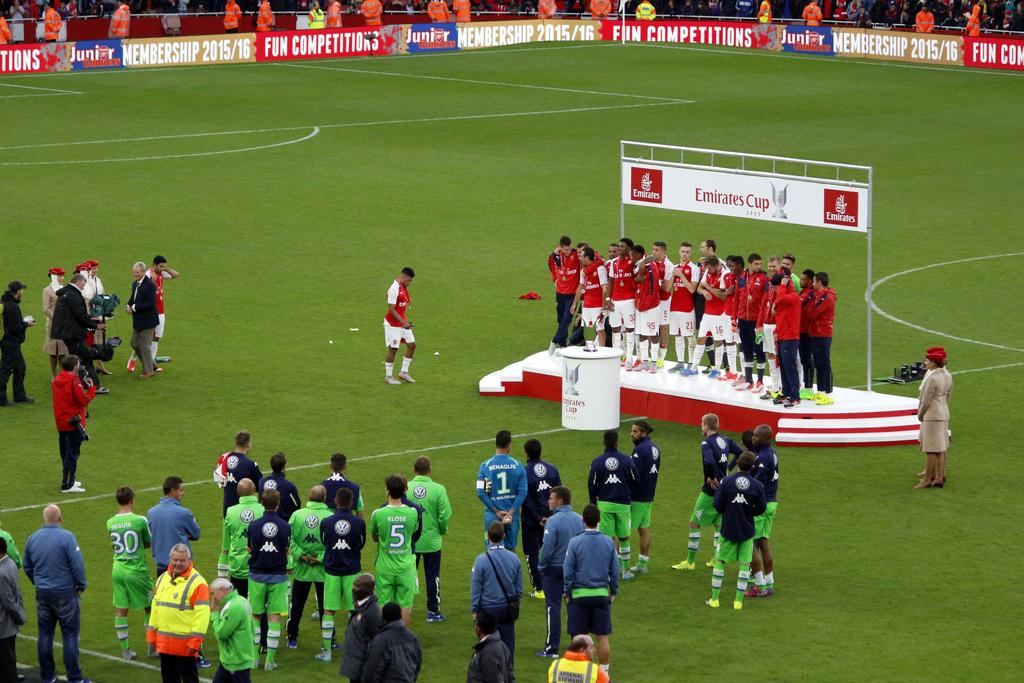<image>
Share a concise interpretation of the image provided. soccer players on a stage that is sponsored by emirates cup 